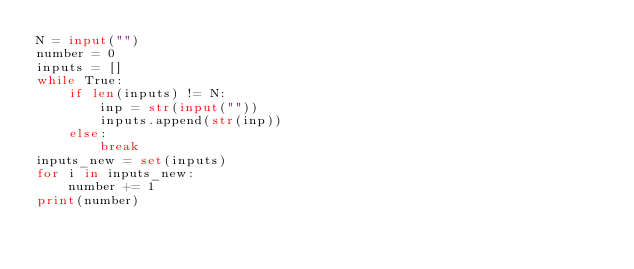Convert code to text. <code><loc_0><loc_0><loc_500><loc_500><_Python_>N = input("")
number = 0
inputs = []
while True:
    if len(inputs) != N:
        inp = str(input(""))
        inputs.append(str(inp))
    else:
        break
inputs_new = set(inputs)
for i in inputs_new:
    number += 1
print(number)</code> 